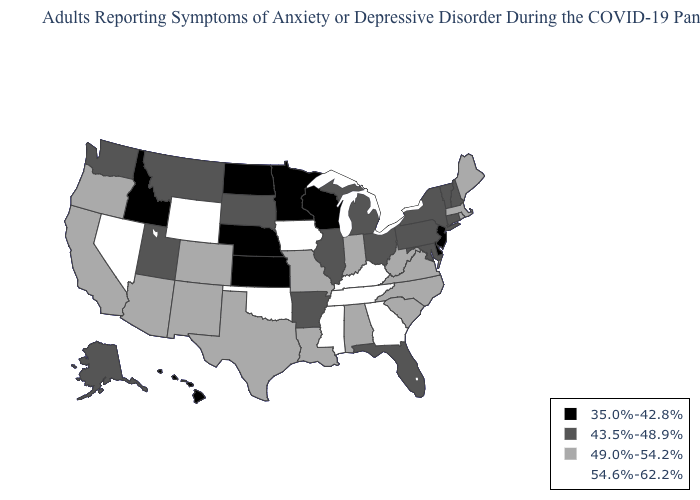Which states hav the highest value in the MidWest?
Give a very brief answer. Iowa. Among the states that border Wisconsin , which have the lowest value?
Short answer required. Minnesota. Name the states that have a value in the range 35.0%-42.8%?
Give a very brief answer. Delaware, Hawaii, Idaho, Kansas, Minnesota, Nebraska, New Jersey, North Dakota, Wisconsin. What is the highest value in states that border Wyoming?
Write a very short answer. 49.0%-54.2%. Name the states that have a value in the range 49.0%-54.2%?
Keep it brief. Alabama, Arizona, California, Colorado, Indiana, Louisiana, Maine, Massachusetts, Missouri, New Mexico, North Carolina, Oregon, Rhode Island, South Carolina, Texas, Virginia, West Virginia. What is the value of Arizona?
Give a very brief answer. 49.0%-54.2%. Name the states that have a value in the range 54.6%-62.2%?
Short answer required. Georgia, Iowa, Kentucky, Mississippi, Nevada, Oklahoma, Tennessee, Wyoming. Which states have the lowest value in the USA?
Give a very brief answer. Delaware, Hawaii, Idaho, Kansas, Minnesota, Nebraska, New Jersey, North Dakota, Wisconsin. What is the value of Massachusetts?
Quick response, please. 49.0%-54.2%. What is the value of Rhode Island?
Keep it brief. 49.0%-54.2%. Name the states that have a value in the range 54.6%-62.2%?
Write a very short answer. Georgia, Iowa, Kentucky, Mississippi, Nevada, Oklahoma, Tennessee, Wyoming. Among the states that border Tennessee , which have the lowest value?
Quick response, please. Arkansas. Which states hav the highest value in the West?
Write a very short answer. Nevada, Wyoming. What is the value of West Virginia?
Concise answer only. 49.0%-54.2%. Among the states that border Louisiana , does Mississippi have the highest value?
Short answer required. Yes. 